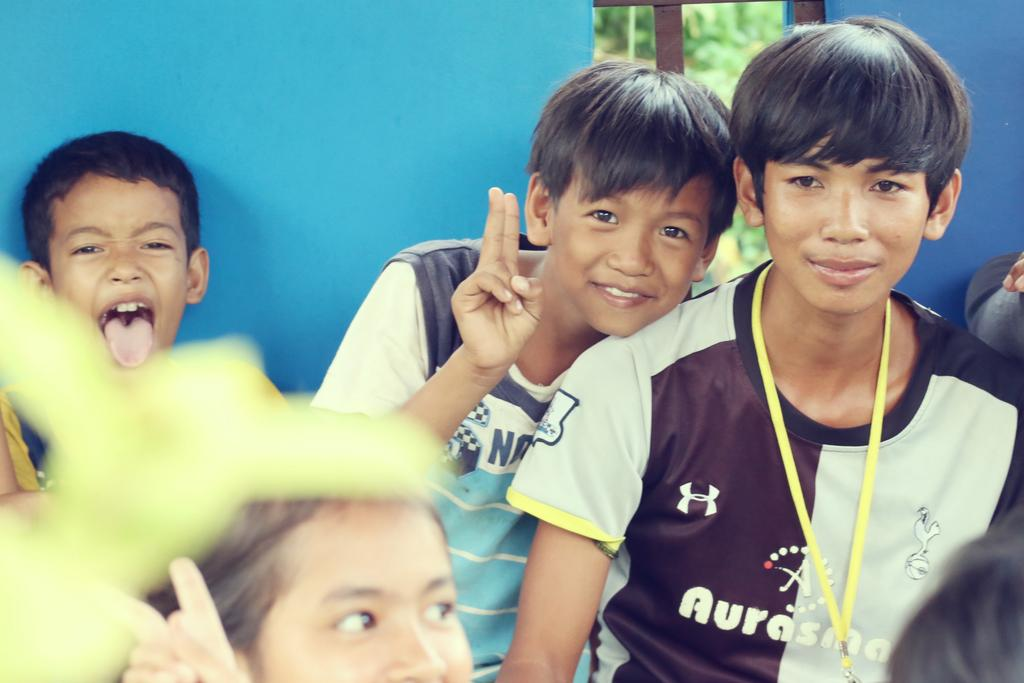<image>
Describe the image concisely. A boy wearing a sports jersey that says Aurasma stands next to another boy, who is holding up two fingers. 